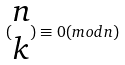Convert formula to latex. <formula><loc_0><loc_0><loc_500><loc_500>( \begin{matrix} n \\ k \end{matrix} ) \equiv 0 ( m o d n )</formula> 